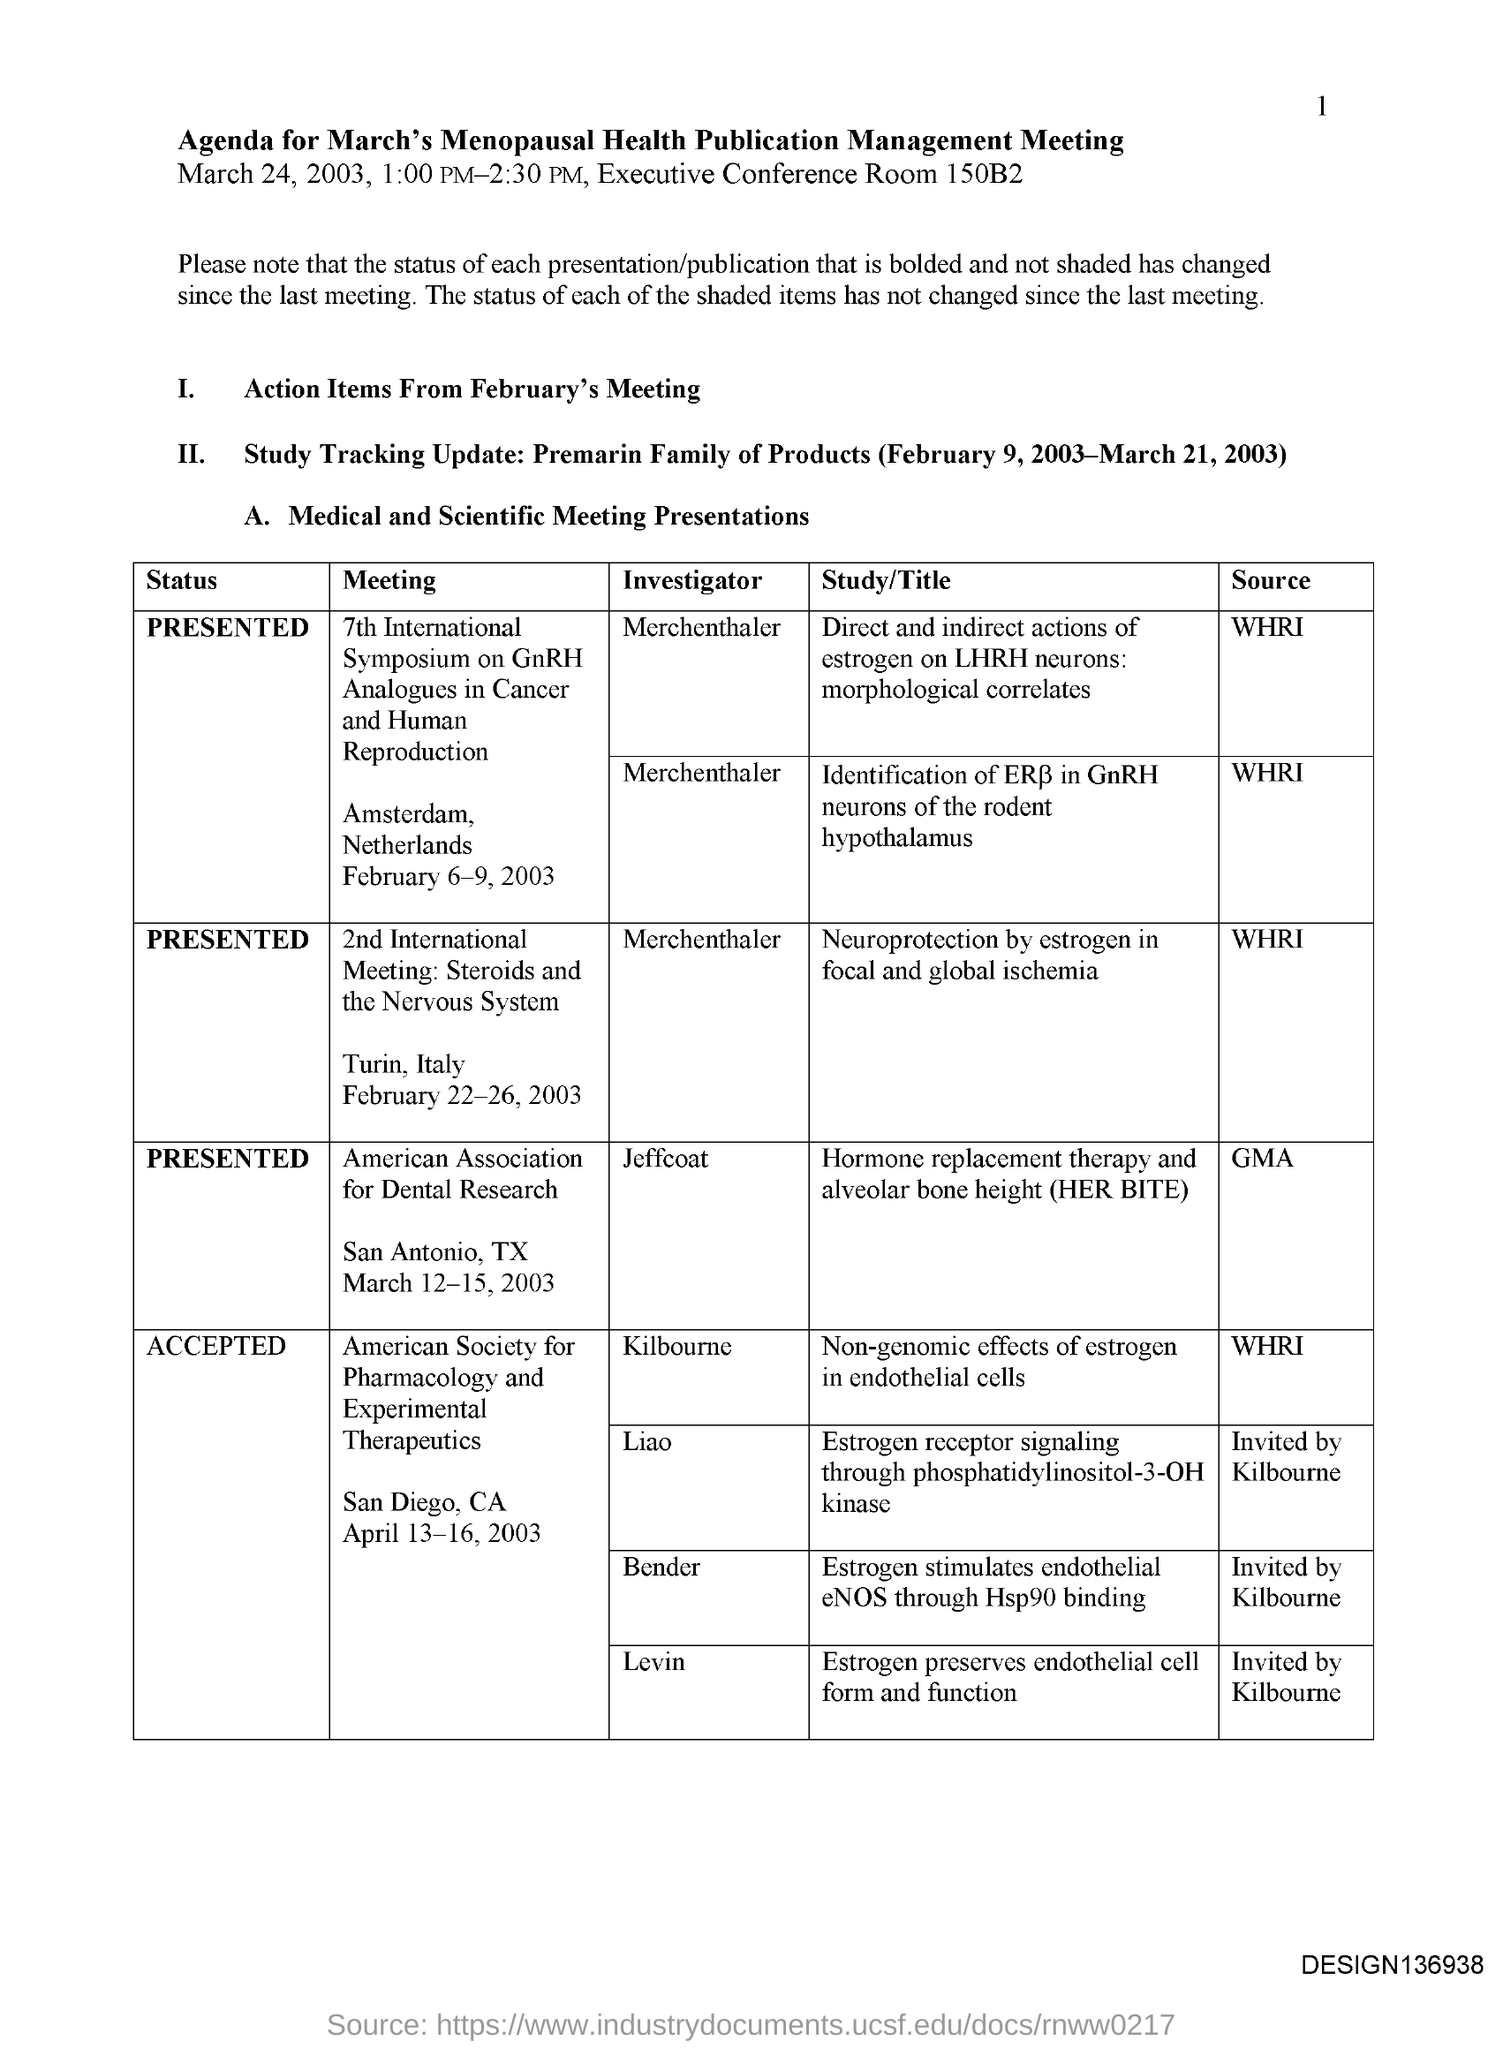Give some essential details in this illustration. This document is titled 'Agenda for March's Menopausal health publication management meeting.' The executive conference room number is 150B2. 